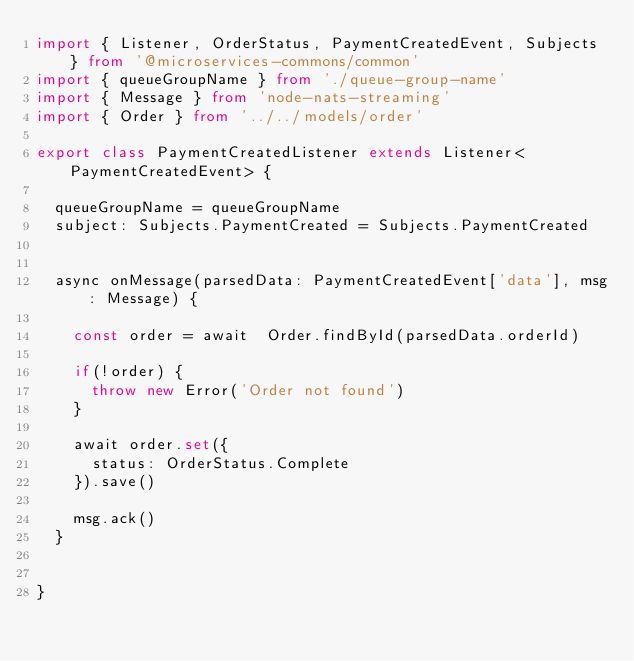<code> <loc_0><loc_0><loc_500><loc_500><_TypeScript_>import { Listener, OrderStatus, PaymentCreatedEvent, Subjects } from '@microservices-commons/common'
import { queueGroupName } from './queue-group-name'
import { Message } from 'node-nats-streaming'
import { Order } from '../../models/order'

export class PaymentCreatedListener extends Listener<PaymentCreatedEvent> {

  queueGroupName = queueGroupName
  subject: Subjects.PaymentCreated = Subjects.PaymentCreated


  async onMessage(parsedData: PaymentCreatedEvent['data'], msg: Message) {

    const order = await  Order.findById(parsedData.orderId)

    if(!order) {
      throw new Error('Order not found')
    }

    await order.set({
      status: OrderStatus.Complete
    }).save()

    msg.ack()
  }


}
</code> 